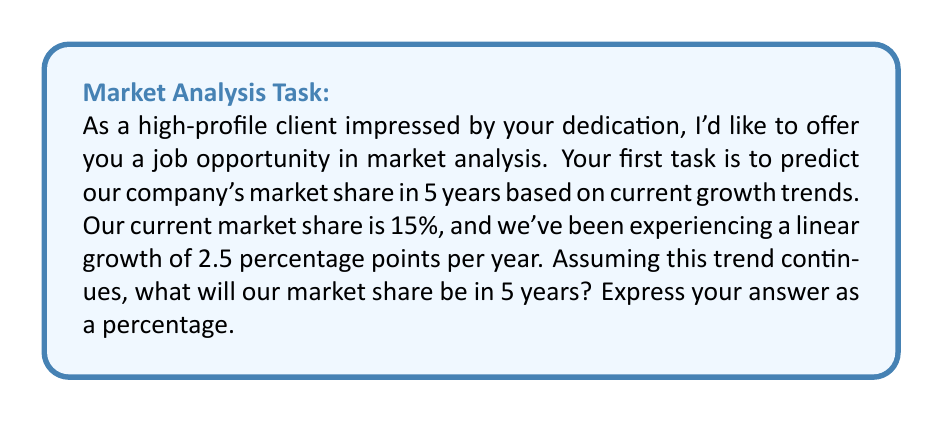Can you solve this math problem? To solve this problem, we need to use a linear equation to model the growth of market share over time. Let's break it down step-by-step:

1. Define variables:
   Let $y$ be the market share (in percentage)
   Let $x$ be the number of years from now

2. Set up the linear equation:
   $y = mx + b$
   Where $m$ is the slope (annual growth rate) and $b$ is the y-intercept (current market share)

3. Plug in the known values:
   $m = 2.5$ (percentage points per year)
   $b = 15$ (current market share percentage)

4. Our equation becomes:
   $y = 2.5x + 15$

5. To find the market share in 5 years, we substitute $x = 5$:
   $y = 2.5(5) + 15$

6. Solve the equation:
   $y = 12.5 + 15 = 27.5$

Therefore, in 5 years, the company's market share will be 27.5%.
Answer: 27.5% 